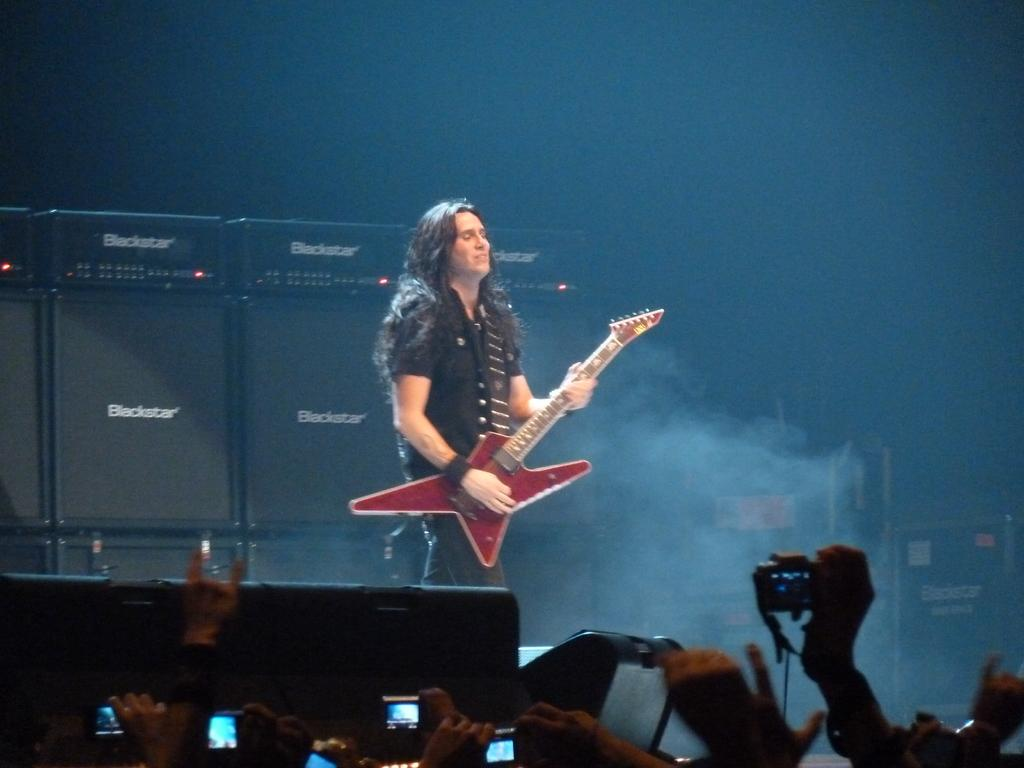What is the man in the image doing? The man is playing the guitar. Who is the man playing the guitar for? There is a group of people in front of the man. What are the people in front of the man doing? The people are standing. What might the people be doing with the camera they are holding? The people are holding a camera in their hands, which suggests they might be taking a picture or recording a video. How does the growth of the plants in the image contribute to the overall atmosphere? There are no plants present in the image, so their growth cannot contribute to the overall atmosphere. 